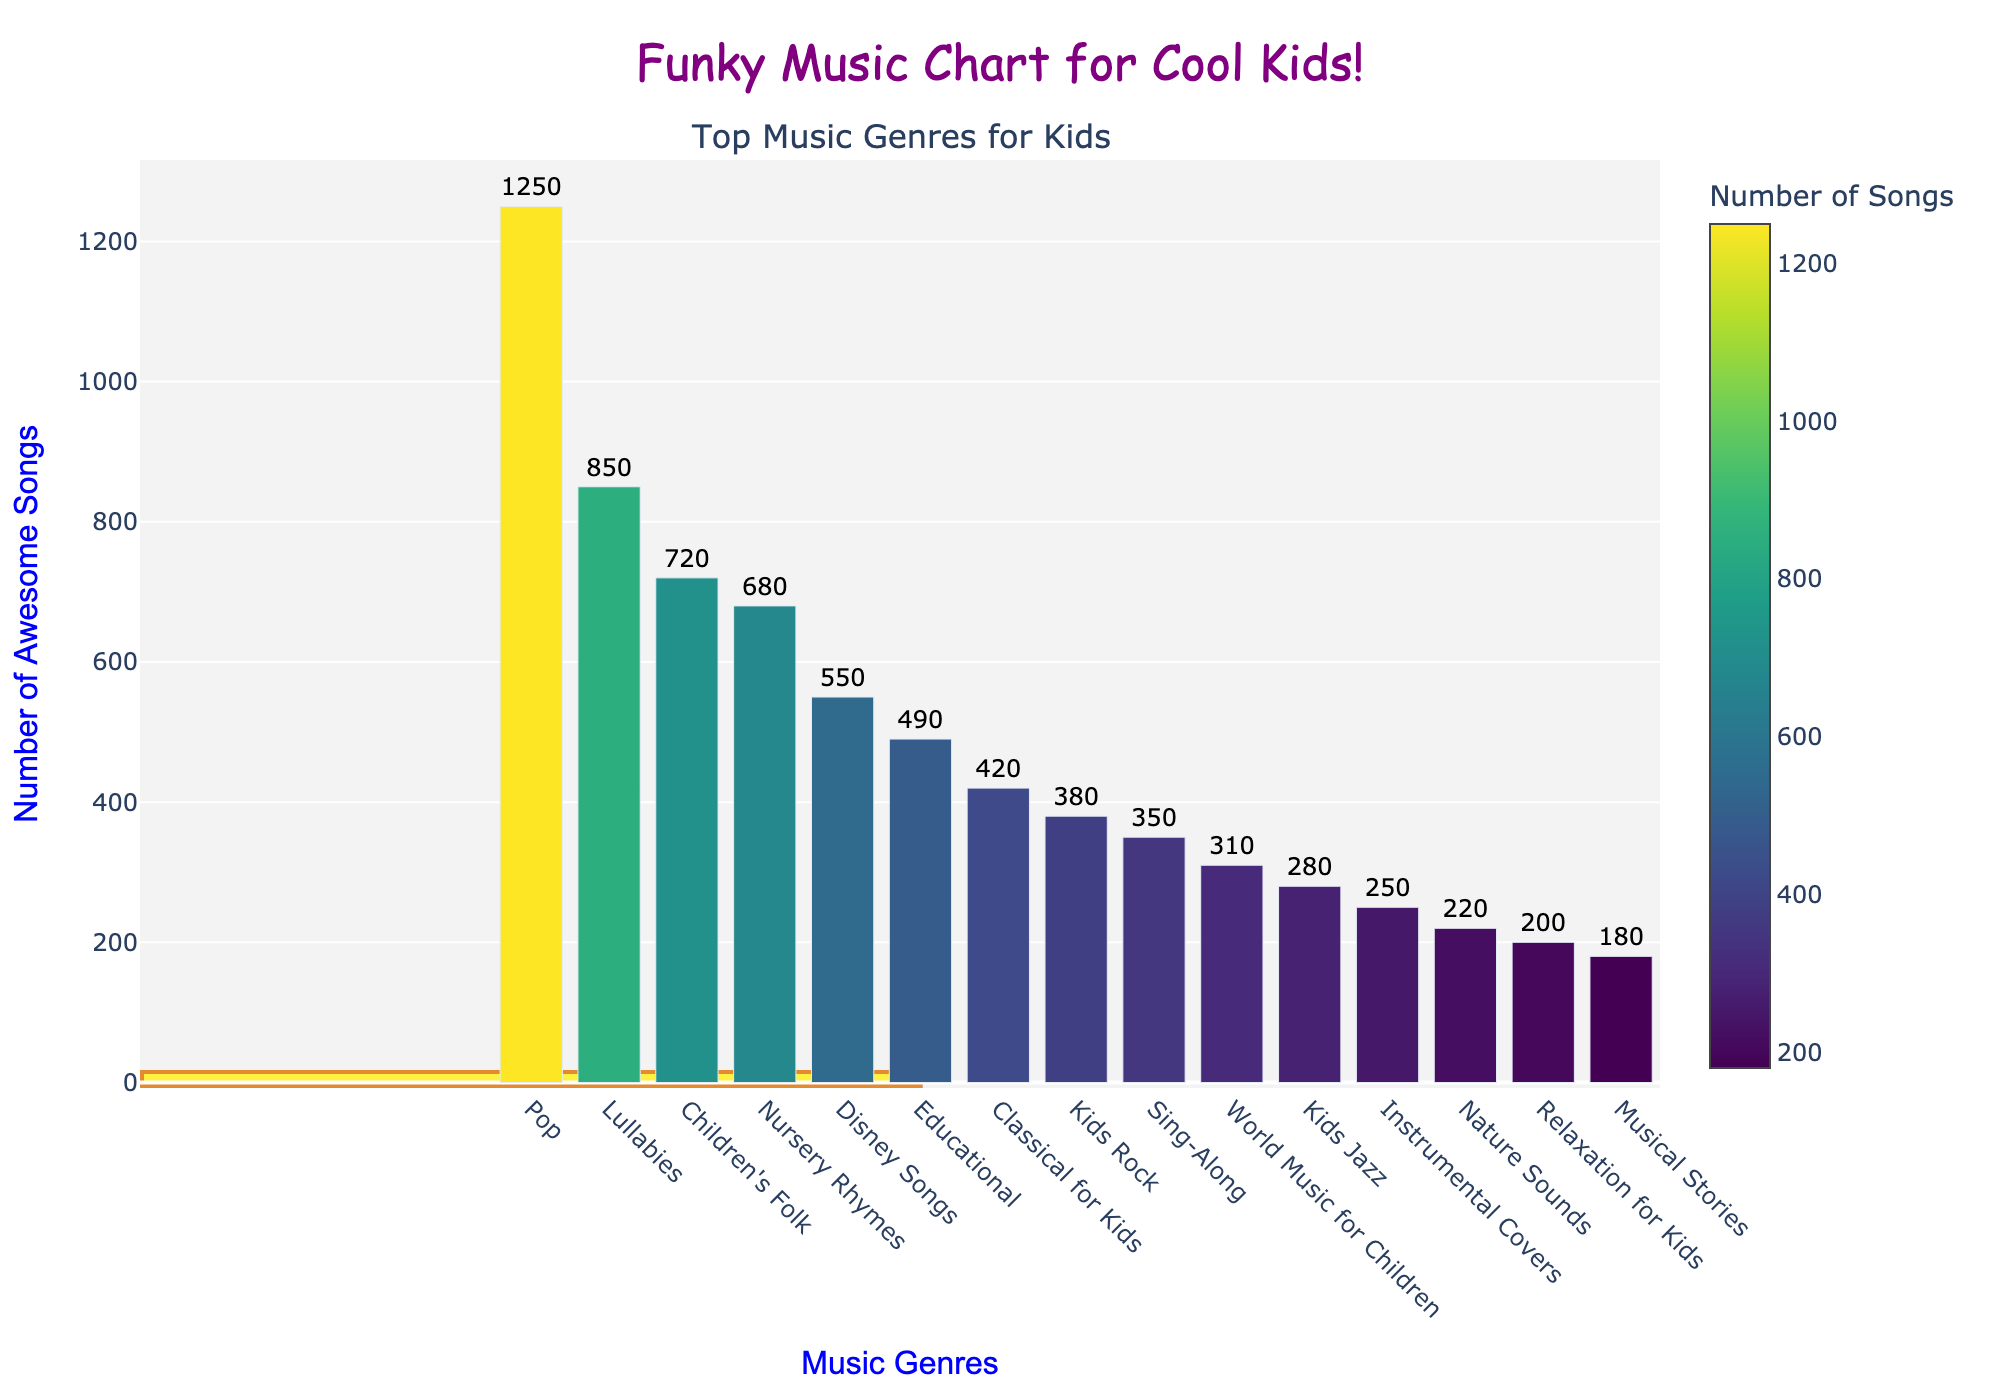How many more Pop songs are there compared to Lullabies? First, find the number of Pop songs (1250) and the number of Lullabies songs (850). Then, subtract the number of Lullabies songs from the number of Pop songs: \(1250 - 850 = 400\)
Answer: 400 Which genre has the fewest number of songs? Identify the genre with the lowest bar in the chart. The bar for Musical Stories is the shortest, which means it has the fewest songs: 180.
Answer: Musical Stories What is the total number of songs in Pop, Lullabies, and Children's Folk? Find the number of songs for each genre: Pop (1250), Lullabies (850), Children's Folk (720). Add them together: \(1250 + 850 + 720 = 2820\)
Answer: 2820 Are there more Nursery Rhymes or Disney Songs? By how much? Find the number of Nursery Rhymes (680) and Disney Songs (550). Then subtract the number of Disney Songs from the number of Nursery Rhymes: \(680 - 550 = 130\)
Answer: Nursery Rhymes, 130 more What is the average number of songs in Educational, Classical for Kids, and Kids Rock genres? Find the number of songs in each genre: Educational (490), Classical for Kids (420), Kids Rock (380). Add them together: \(490 + 420 + 380 = 1290\). Then divide by the number of genres (3): \(1290 / 3 = 430\)
Answer: 430 Which is the second most popular genre based on the number of songs? Look at the heights of the bars and identify the second tallest bar after Pop (1250). The second tallest bar is Lullabies (850).
Answer: Lullabies Are there more than 500 songs in the Disney Songs genre? Look at the bar for Disney Songs. The height corresponds to 550, which is more than 500.
Answer: Yes How many genres have fewer songs than Children's Folk? Determine the number of songs in Children's Folk (720). Count the number of genres with bars shorter than the Children's Folk bar (Lullabies - 850, Pop - 1250 are taller, all others are shorter): 11 genres (Nursery Rhymes, Disney Songs, Educational, Classical for Kids, Kids Rock, Sing-Along, World Music for Children, Kids Jazz, Instrumental Covers, Nature Sounds, Relaxation for Kids, Musical Stories).
Answer: 11 Which genres have between 300 and 700 songs? Identify the genres with bars that fall within the range of 300 to 700 songs. These are: Children's Folk (720), Nursery Rhymes (680), and World Music for Children (310).
Answer: World Music for Children Is the number of songs in Kids Rock closer to the number of songs in Instrumental Covers or in Classical for Kids? Find the number of songs in Kids Rock (380), Instrumental Covers (250), and Classical for Kids (420). Calculate the differences: \(380 - 250 = 130\) and \(420 - 380 = 40\). The Kids Rock number (380) is closer to Classical for Kids (420) because the difference is smaller (40).
Answer: Classical for Kids 